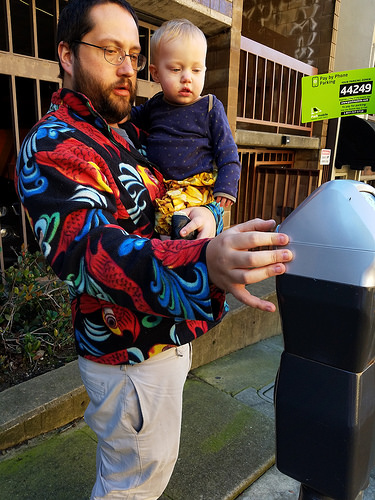<image>
Can you confirm if the child is on the man hand? Yes. Looking at the image, I can see the child is positioned on top of the man hand, with the man hand providing support. Where is the glasses in relation to the man? Is it on the man? Yes. Looking at the image, I can see the glasses is positioned on top of the man, with the man providing support. 